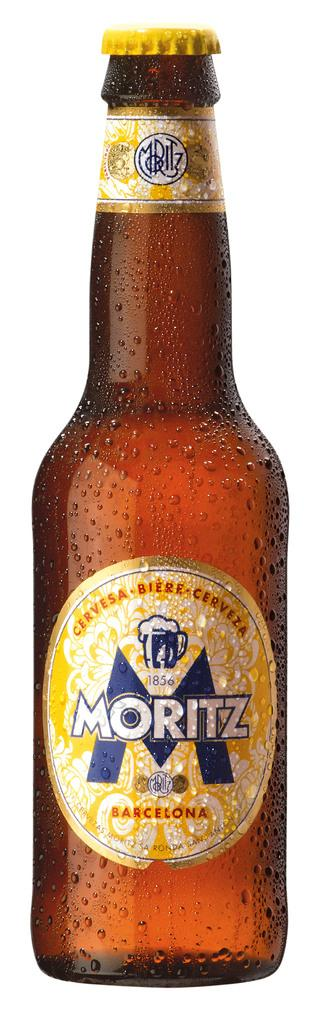<image>
Give a short and clear explanation of the subsequent image. a bottle of ceryesa biere cerveza moritz barcelona 